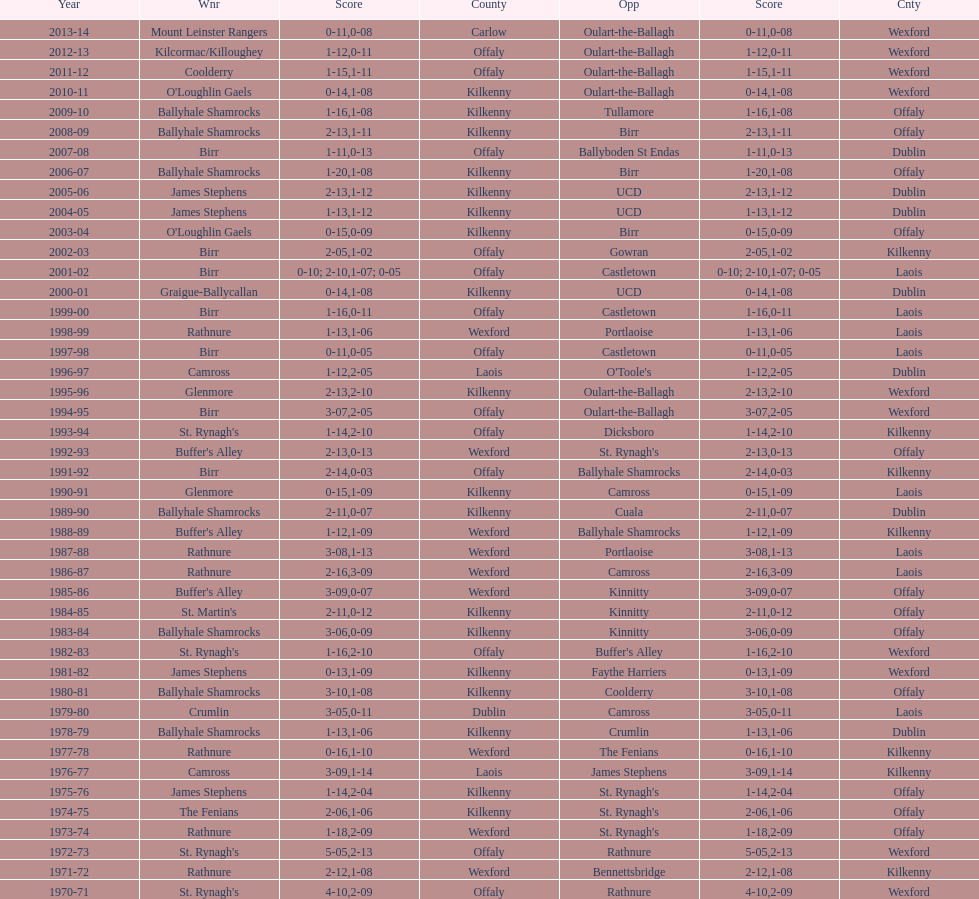I'm looking to parse the entire table for insights. Could you assist me with that? {'header': ['Year', 'Wnr', 'Score', 'County', 'Opp', 'Score', 'Cnty'], 'rows': [['2013-14', 'Mount Leinster Rangers', '0-11', 'Carlow', 'Oulart-the-Ballagh', '0-08', 'Wexford'], ['2012-13', 'Kilcormac/Killoughey', '1-12', 'Offaly', 'Oulart-the-Ballagh', '0-11', 'Wexford'], ['2011-12', 'Coolderry', '1-15', 'Offaly', 'Oulart-the-Ballagh', '1-11', 'Wexford'], ['2010-11', "O'Loughlin Gaels", '0-14', 'Kilkenny', 'Oulart-the-Ballagh', '1-08', 'Wexford'], ['2009-10', 'Ballyhale Shamrocks', '1-16', 'Kilkenny', 'Tullamore', '1-08', 'Offaly'], ['2008-09', 'Ballyhale Shamrocks', '2-13', 'Kilkenny', 'Birr', '1-11', 'Offaly'], ['2007-08', 'Birr', '1-11', 'Offaly', 'Ballyboden St Endas', '0-13', 'Dublin'], ['2006-07', 'Ballyhale Shamrocks', '1-20', 'Kilkenny', 'Birr', '1-08', 'Offaly'], ['2005-06', 'James Stephens', '2-13', 'Kilkenny', 'UCD', '1-12', 'Dublin'], ['2004-05', 'James Stephens', '1-13', 'Kilkenny', 'UCD', '1-12', 'Dublin'], ['2003-04', "O'Loughlin Gaels", '0-15', 'Kilkenny', 'Birr', '0-09', 'Offaly'], ['2002-03', 'Birr', '2-05', 'Offaly', 'Gowran', '1-02', 'Kilkenny'], ['2001-02', 'Birr', '0-10; 2-10', 'Offaly', 'Castletown', '1-07; 0-05', 'Laois'], ['2000-01', 'Graigue-Ballycallan', '0-14', 'Kilkenny', 'UCD', '1-08', 'Dublin'], ['1999-00', 'Birr', '1-16', 'Offaly', 'Castletown', '0-11', 'Laois'], ['1998-99', 'Rathnure', '1-13', 'Wexford', 'Portlaoise', '1-06', 'Laois'], ['1997-98', 'Birr', '0-11', 'Offaly', 'Castletown', '0-05', 'Laois'], ['1996-97', 'Camross', '1-12', 'Laois', "O'Toole's", '2-05', 'Dublin'], ['1995-96', 'Glenmore', '2-13', 'Kilkenny', 'Oulart-the-Ballagh', '2-10', 'Wexford'], ['1994-95', 'Birr', '3-07', 'Offaly', 'Oulart-the-Ballagh', '2-05', 'Wexford'], ['1993-94', "St. Rynagh's", '1-14', 'Offaly', 'Dicksboro', '2-10', 'Kilkenny'], ['1992-93', "Buffer's Alley", '2-13', 'Wexford', "St. Rynagh's", '0-13', 'Offaly'], ['1991-92', 'Birr', '2-14', 'Offaly', 'Ballyhale Shamrocks', '0-03', 'Kilkenny'], ['1990-91', 'Glenmore', '0-15', 'Kilkenny', 'Camross', '1-09', 'Laois'], ['1989-90', 'Ballyhale Shamrocks', '2-11', 'Kilkenny', 'Cuala', '0-07', 'Dublin'], ['1988-89', "Buffer's Alley", '1-12', 'Wexford', 'Ballyhale Shamrocks', '1-09', 'Kilkenny'], ['1987-88', 'Rathnure', '3-08', 'Wexford', 'Portlaoise', '1-13', 'Laois'], ['1986-87', 'Rathnure', '2-16', 'Wexford', 'Camross', '3-09', 'Laois'], ['1985-86', "Buffer's Alley", '3-09', 'Wexford', 'Kinnitty', '0-07', 'Offaly'], ['1984-85', "St. Martin's", '2-11', 'Kilkenny', 'Kinnitty', '0-12', 'Offaly'], ['1983-84', 'Ballyhale Shamrocks', '3-06', 'Kilkenny', 'Kinnitty', '0-09', 'Offaly'], ['1982-83', "St. Rynagh's", '1-16', 'Offaly', "Buffer's Alley", '2-10', 'Wexford'], ['1981-82', 'James Stephens', '0-13', 'Kilkenny', 'Faythe Harriers', '1-09', 'Wexford'], ['1980-81', 'Ballyhale Shamrocks', '3-10', 'Kilkenny', 'Coolderry', '1-08', 'Offaly'], ['1979-80', 'Crumlin', '3-05', 'Dublin', 'Camross', '0-11', 'Laois'], ['1978-79', 'Ballyhale Shamrocks', '1-13', 'Kilkenny', 'Crumlin', '1-06', 'Dublin'], ['1977-78', 'Rathnure', '0-16', 'Wexford', 'The Fenians', '1-10', 'Kilkenny'], ['1976-77', 'Camross', '3-09', 'Laois', 'James Stephens', '1-14', 'Kilkenny'], ['1975-76', 'James Stephens', '1-14', 'Kilkenny', "St. Rynagh's", '2-04', 'Offaly'], ['1974-75', 'The Fenians', '2-06', 'Kilkenny', "St. Rynagh's", '1-06', 'Offaly'], ['1973-74', 'Rathnure', '1-18', 'Wexford', "St. Rynagh's", '2-09', 'Offaly'], ['1972-73', "St. Rynagh's", '5-05', 'Offaly', 'Rathnure', '2-13', 'Wexford'], ['1971-72', 'Rathnure', '2-12', 'Wexford', 'Bennettsbridge', '1-08', 'Kilkenny'], ['1970-71', "St. Rynagh's", '4-10', 'Offaly', 'Rathnure', '2-09', 'Wexford']]} Which winner is next to mount leinster rangers? Kilcormac/Killoughey. 